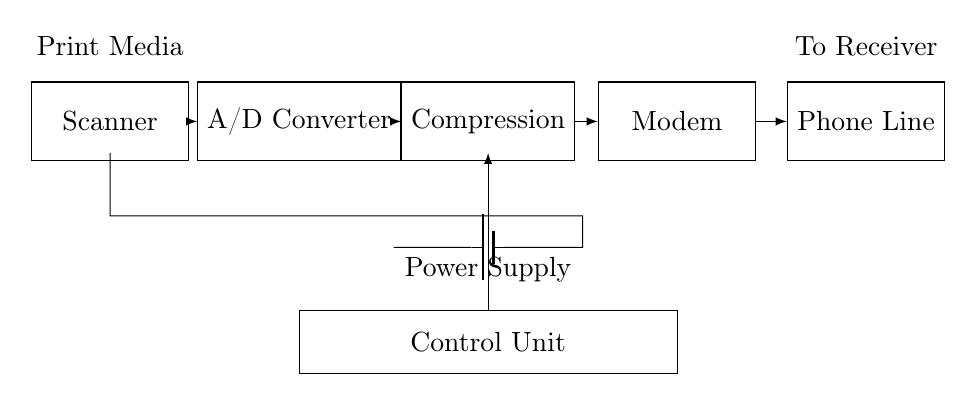What component initiates the process of transmitting print media? The scanner is the first component that takes the print media and converts it into a format suitable for processing.
Answer: Scanner What follows the Analog-to-Digital Converter in the circuit? After the A/D Converter, the signal is sent to the Compression component, which reduces the file size before transmission.
Answer: Compression What role does the modem play in the circuit? The modem modulates the digital signal into an analog format suitable for transmission over the phone line, enabling communication.
Answer: Modem How many stages are there in the transmission path from the scanner to the phone line? There are four stages: Scanner, A/D Converter, Compression, and Modem, before reaching the phone line for transmission.
Answer: Four What is the source of power for the circuit? The Power Supply provides the necessary electrical energy for all components within the circuit to function properly.
Answer: Power Supply In which part of the circuit does decision-making occur? The Control Unit is responsible for managing the operations of other components, coordinating the transmission of data through the circuit.
Answer: Control Unit What type of connection exists between the modem and phone line? A direct connection ensures that the modulated signal from the modem is sent directly to the phone line for transmission.
Answer: Direct connection 